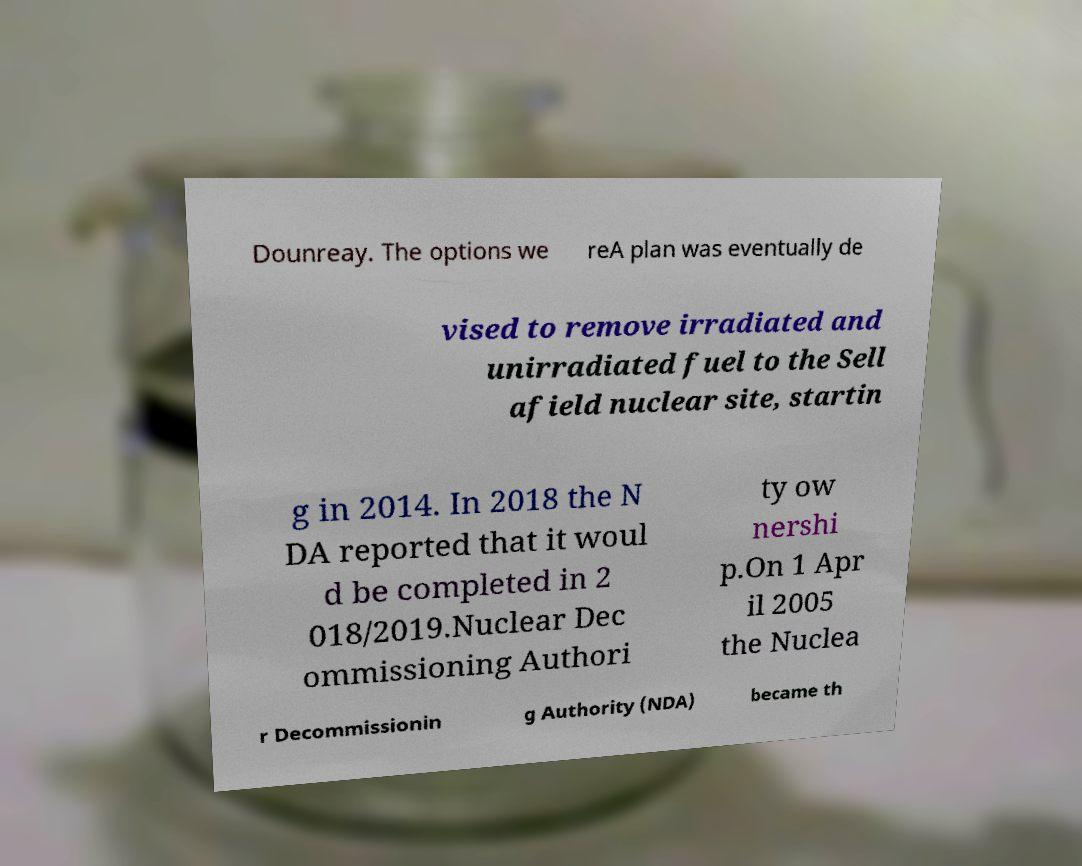Please read and relay the text visible in this image. What does it say? Dounreay. The options we reA plan was eventually de vised to remove irradiated and unirradiated fuel to the Sell afield nuclear site, startin g in 2014. In 2018 the N DA reported that it woul d be completed in 2 018/2019.Nuclear Dec ommissioning Authori ty ow nershi p.On 1 Apr il 2005 the Nuclea r Decommissionin g Authority (NDA) became th 